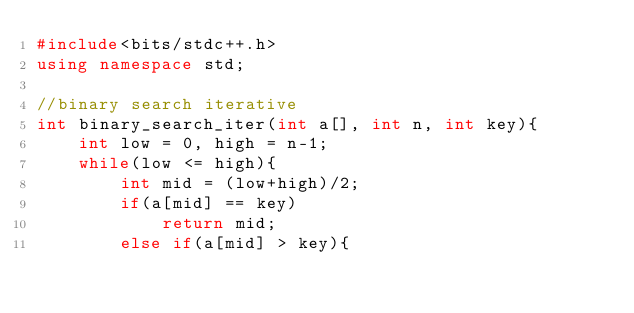Convert code to text. <code><loc_0><loc_0><loc_500><loc_500><_C++_>#include<bits/stdc++.h>
using namespace std;

//binary search iterative
int binary_search_iter(int a[], int n, int key){
    int low = 0, high = n-1;
    while(low <= high){
        int mid = (low+high)/2;
        if(a[mid] == key)
            return mid;
        else if(a[mid] > key){</code> 